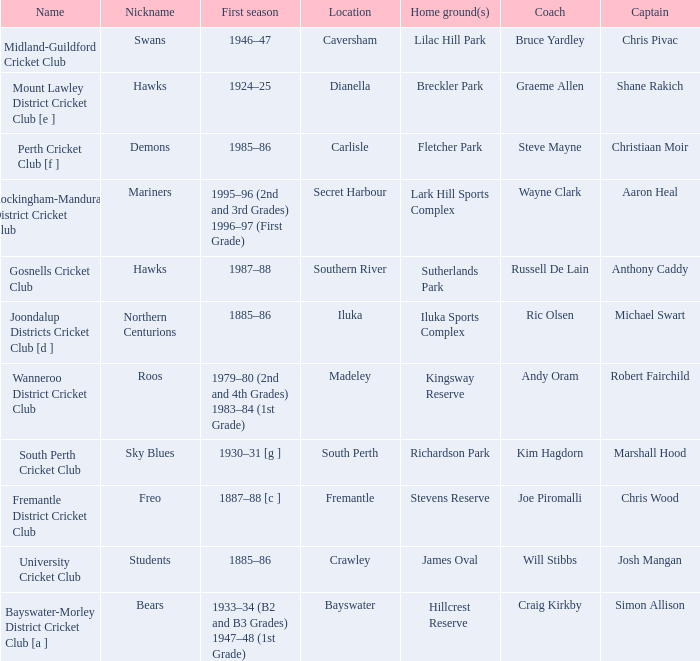What is the dates where Hillcrest Reserve is the home grounds? 1933–34 (B2 and B3 Grades) 1947–48 (1st Grade). 